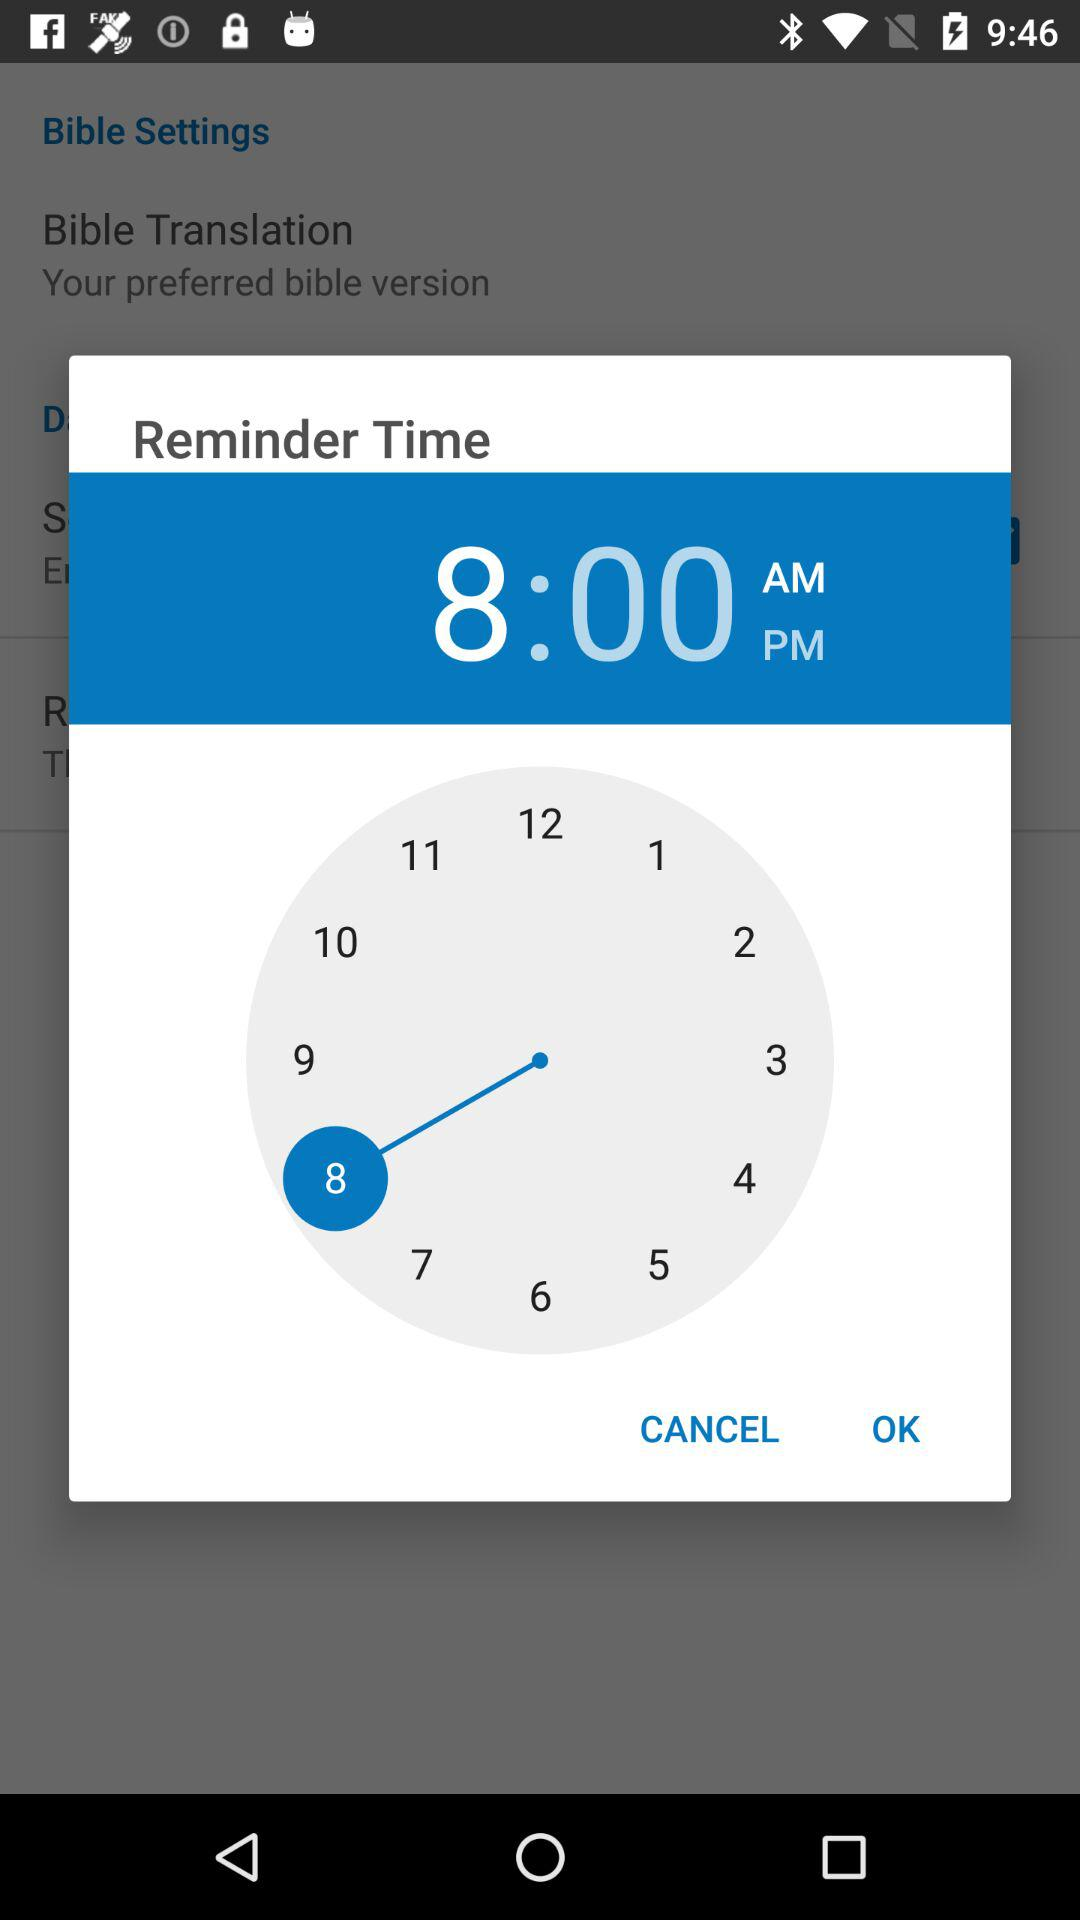What's the selected time? The selected time is 8:00 AM. 